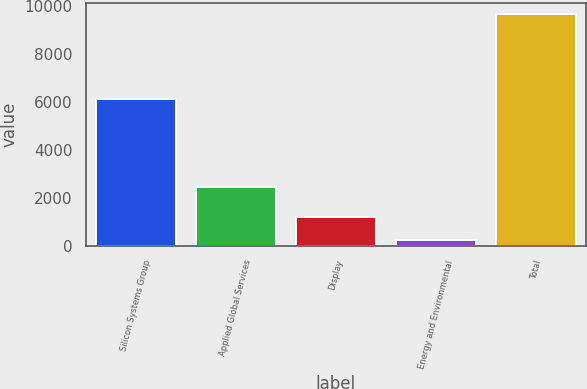Convert chart to OTSL. <chart><loc_0><loc_0><loc_500><loc_500><bar_chart><fcel>Silicon Systems Group<fcel>Applied Global Services<fcel>Display<fcel>Energy and Environmental<fcel>Total<nl><fcel>6132<fcel>2433<fcel>1179<fcel>238<fcel>9648<nl></chart> 